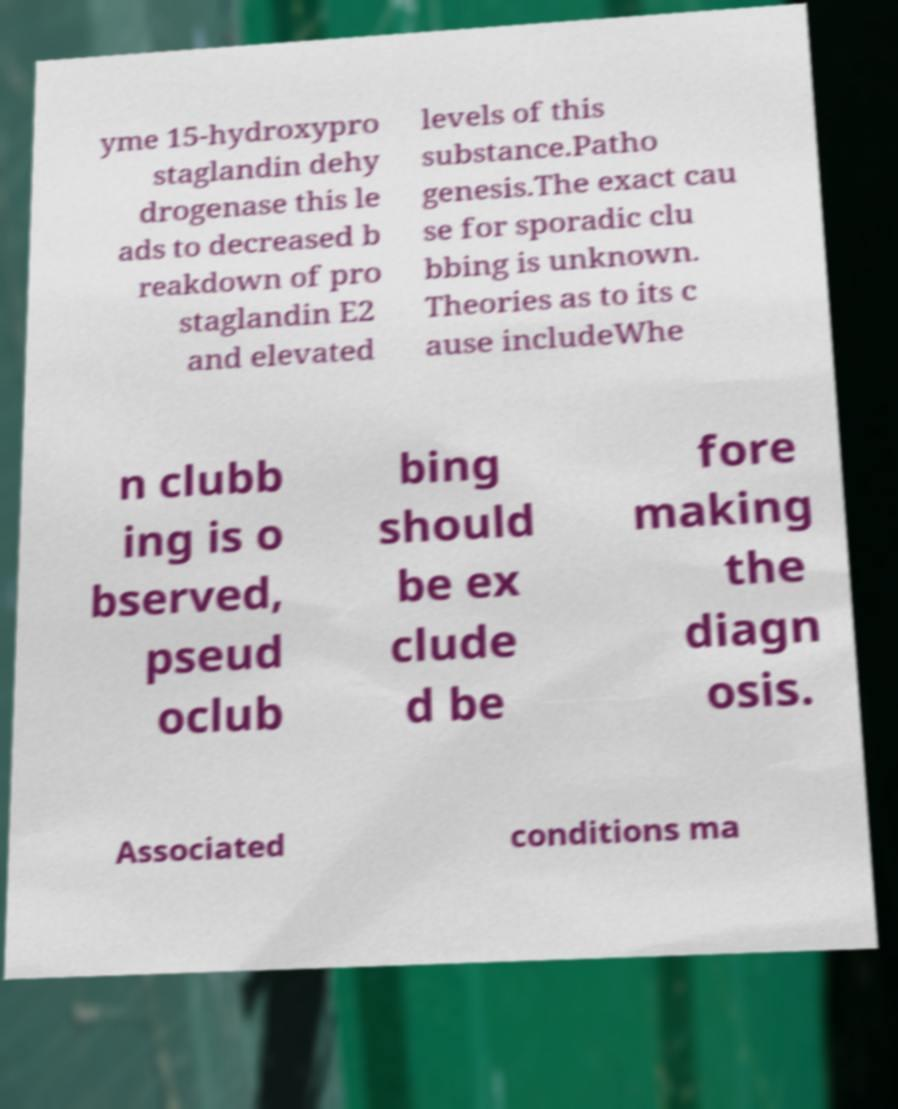Could you extract and type out the text from this image? yme 15-hydroxypro staglandin dehy drogenase this le ads to decreased b reakdown of pro staglandin E2 and elevated levels of this substance.Patho genesis.The exact cau se for sporadic clu bbing is unknown. Theories as to its c ause includeWhe n clubb ing is o bserved, pseud oclub bing should be ex clude d be fore making the diagn osis. Associated conditions ma 